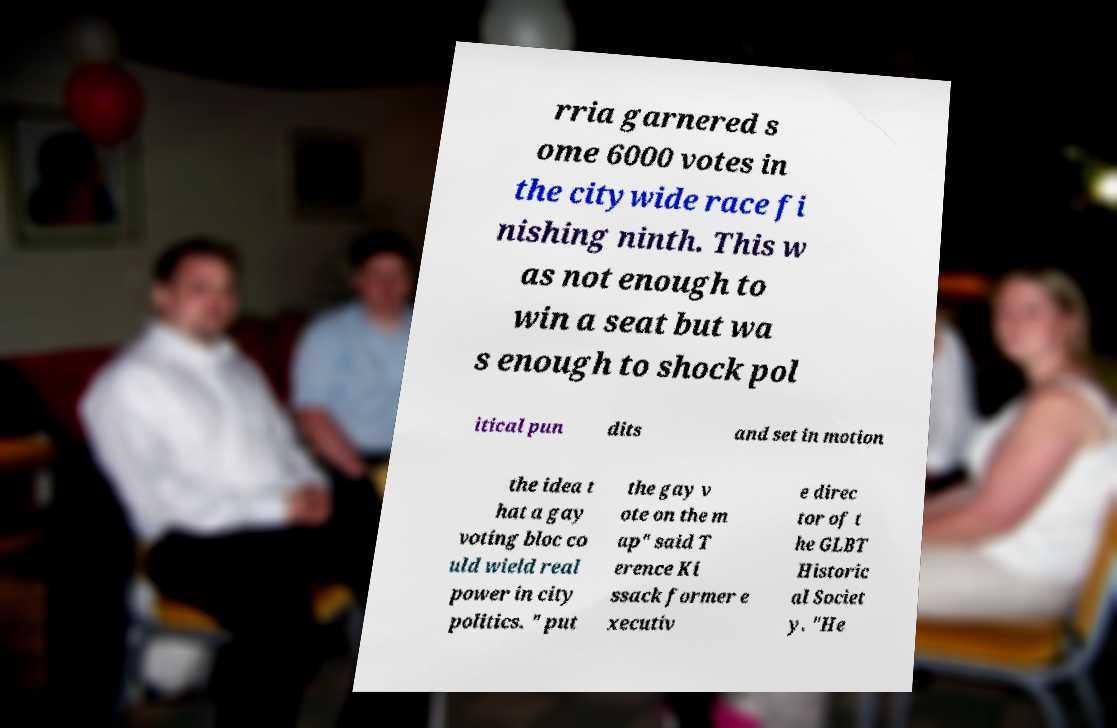Could you assist in decoding the text presented in this image and type it out clearly? rria garnered s ome 6000 votes in the citywide race fi nishing ninth. This w as not enough to win a seat but wa s enough to shock pol itical pun dits and set in motion the idea t hat a gay voting bloc co uld wield real power in city politics. " put the gay v ote on the m ap" said T erence Ki ssack former e xecutiv e direc tor of t he GLBT Historic al Societ y. "He 